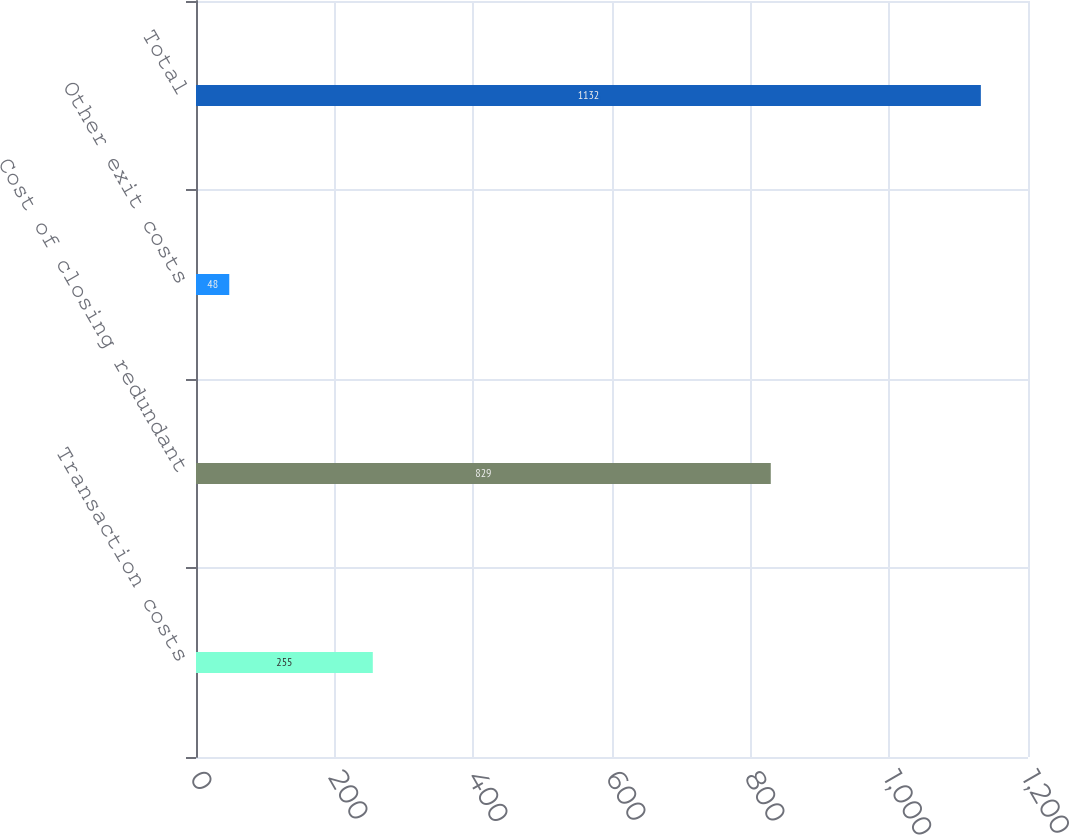Convert chart. <chart><loc_0><loc_0><loc_500><loc_500><bar_chart><fcel>Transaction costs<fcel>Cost of closing redundant<fcel>Other exit costs<fcel>Total<nl><fcel>255<fcel>829<fcel>48<fcel>1132<nl></chart> 